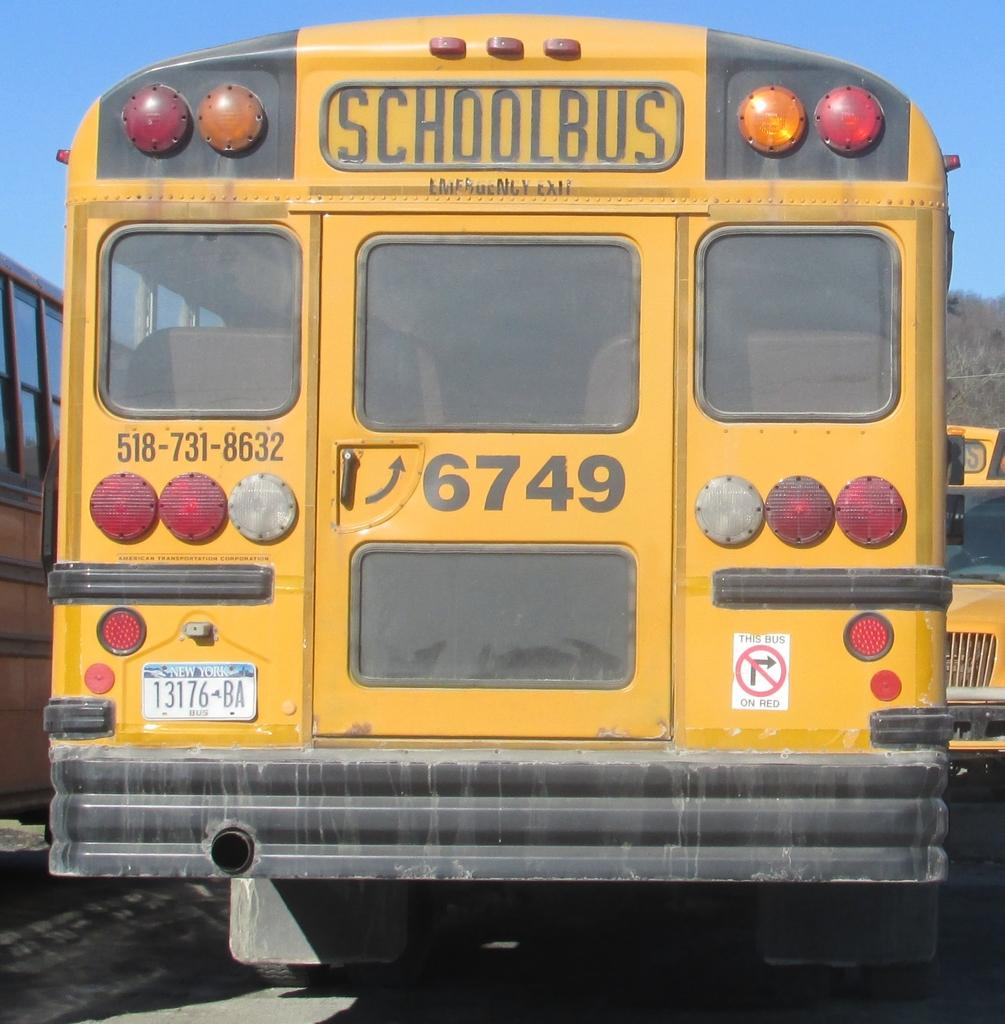<image>
Relay a brief, clear account of the picture shown. A yellow school bus with the number 6749 on the back. 